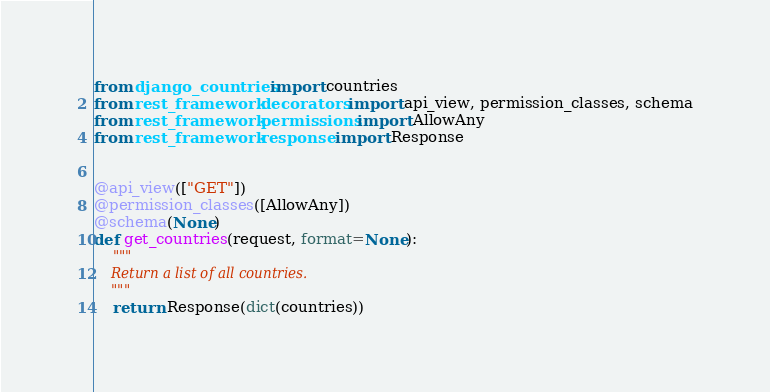<code> <loc_0><loc_0><loc_500><loc_500><_Python_>from django_countries import countries
from rest_framework.decorators import api_view, permission_classes, schema
from rest_framework.permissions import AllowAny
from rest_framework.response import Response


@api_view(["GET"])
@permission_classes([AllowAny])
@schema(None)
def get_countries(request, format=None):
    """
    Return a list of all countries.
    """
    return Response(dict(countries))
</code> 